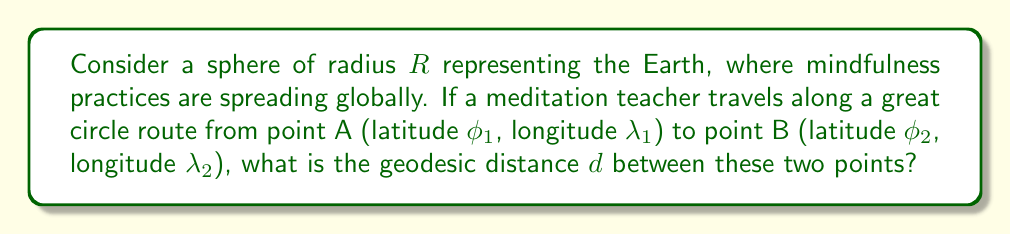Solve this math problem. To solve this problem, we'll use the Haversine formula, which is ideal for calculating great-circle distances on a sphere:

1) First, we define the haversine function: 
   $\text{hav}(\theta) = \sin^2(\frac{\theta}{2})$

2) The Haversine formula for the central angle $\theta$ between two points is:
   $$\text{hav}(\theta) = \text{hav}(\phi_2 - \phi_1) + \cos(\phi_1)\cos(\phi_2)\text{hav}(\lambda_2 - \lambda_1)$$

3) Rearranging this equation, we get:
   $$\theta = 2 \arcsin(\sqrt{\sin^2(\frac{\phi_2 - \phi_1}{2}) + \cos(\phi_1)\cos(\phi_2)\sin^2(\frac{\lambda_2 - \lambda_1}{2})})$$

4) The geodesic distance $d$ is then given by:
   $$d = R\theta$$

5) Substituting the expression for $\theta$, we get our final formula:
   $$d = 2R \arcsin(\sqrt{\sin^2(\frac{\phi_2 - \phi_1}{2}) + \cos(\phi_1)\cos(\phi_2)\sin^2(\frac{\lambda_2 - \lambda_1}{2})})$$

This formula gives the shortest distance between two points on a sphere, which represents the path of global mindfulness practices spreading along geodesics.

[asy]
import geometry;

size(200);
draw(Circle((0,0),1));
dot((0.6,0.8),red);
dot((-0.7,-0.7),red);
draw(arc((0,0),1,45,225),blue);
label("A",(0.7,0.9),N);
label("B",(-0.8,-0.8),SW);
label("Geodesic",(-0.2,0.2),NW);
[/asy]
Answer: $d = 2R \arcsin(\sqrt{\sin^2(\frac{\phi_2 - \phi_1}{2}) + \cos(\phi_1)\cos(\phi_2)\sin^2(\frac{\lambda_2 - \lambda_1}{2})})$ 